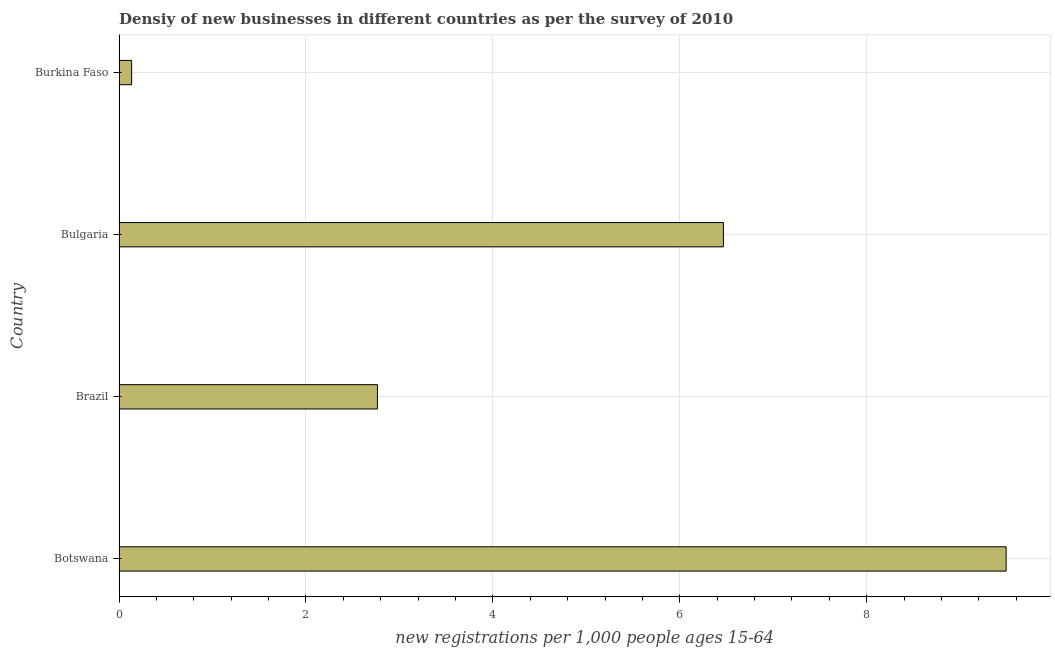Does the graph contain grids?
Your answer should be compact. Yes. What is the title of the graph?
Your response must be concise. Densiy of new businesses in different countries as per the survey of 2010. What is the label or title of the X-axis?
Your answer should be compact. New registrations per 1,0 people ages 15-64. What is the label or title of the Y-axis?
Ensure brevity in your answer.  Country. What is the density of new business in Botswana?
Your answer should be compact. 9.49. Across all countries, what is the maximum density of new business?
Provide a succinct answer. 9.49. Across all countries, what is the minimum density of new business?
Your response must be concise. 0.13. In which country was the density of new business maximum?
Ensure brevity in your answer.  Botswana. In which country was the density of new business minimum?
Provide a short and direct response. Burkina Faso. What is the sum of the density of new business?
Offer a very short reply. 18.86. What is the difference between the density of new business in Botswana and Burkina Faso?
Make the answer very short. 9.36. What is the average density of new business per country?
Offer a very short reply. 4.71. What is the median density of new business?
Give a very brief answer. 4.62. What is the ratio of the density of new business in Bulgaria to that in Burkina Faso?
Offer a very short reply. 48.12. Is the density of new business in Botswana less than that in Bulgaria?
Your response must be concise. No. What is the difference between the highest and the second highest density of new business?
Your response must be concise. 3.02. Is the sum of the density of new business in Bulgaria and Burkina Faso greater than the maximum density of new business across all countries?
Ensure brevity in your answer.  No. What is the difference between the highest and the lowest density of new business?
Give a very brief answer. 9.36. In how many countries, is the density of new business greater than the average density of new business taken over all countries?
Your answer should be very brief. 2. How many bars are there?
Your answer should be compact. 4. How many countries are there in the graph?
Your answer should be compact. 4. What is the difference between two consecutive major ticks on the X-axis?
Give a very brief answer. 2. What is the new registrations per 1,000 people ages 15-64 in Botswana?
Your answer should be compact. 9.49. What is the new registrations per 1,000 people ages 15-64 in Brazil?
Your response must be concise. 2.76. What is the new registrations per 1,000 people ages 15-64 of Bulgaria?
Provide a short and direct response. 6.47. What is the new registrations per 1,000 people ages 15-64 of Burkina Faso?
Your response must be concise. 0.13. What is the difference between the new registrations per 1,000 people ages 15-64 in Botswana and Brazil?
Ensure brevity in your answer.  6.73. What is the difference between the new registrations per 1,000 people ages 15-64 in Botswana and Bulgaria?
Your answer should be very brief. 3.03. What is the difference between the new registrations per 1,000 people ages 15-64 in Botswana and Burkina Faso?
Provide a succinct answer. 9.36. What is the difference between the new registrations per 1,000 people ages 15-64 in Brazil and Bulgaria?
Your answer should be very brief. -3.7. What is the difference between the new registrations per 1,000 people ages 15-64 in Brazil and Burkina Faso?
Your response must be concise. 2.63. What is the difference between the new registrations per 1,000 people ages 15-64 in Bulgaria and Burkina Faso?
Your answer should be very brief. 6.33. What is the ratio of the new registrations per 1,000 people ages 15-64 in Botswana to that in Brazil?
Provide a succinct answer. 3.43. What is the ratio of the new registrations per 1,000 people ages 15-64 in Botswana to that in Bulgaria?
Keep it short and to the point. 1.47. What is the ratio of the new registrations per 1,000 people ages 15-64 in Botswana to that in Burkina Faso?
Your response must be concise. 70.63. What is the ratio of the new registrations per 1,000 people ages 15-64 in Brazil to that in Bulgaria?
Make the answer very short. 0.43. What is the ratio of the new registrations per 1,000 people ages 15-64 in Brazil to that in Burkina Faso?
Make the answer very short. 20.57. What is the ratio of the new registrations per 1,000 people ages 15-64 in Bulgaria to that in Burkina Faso?
Offer a very short reply. 48.12. 